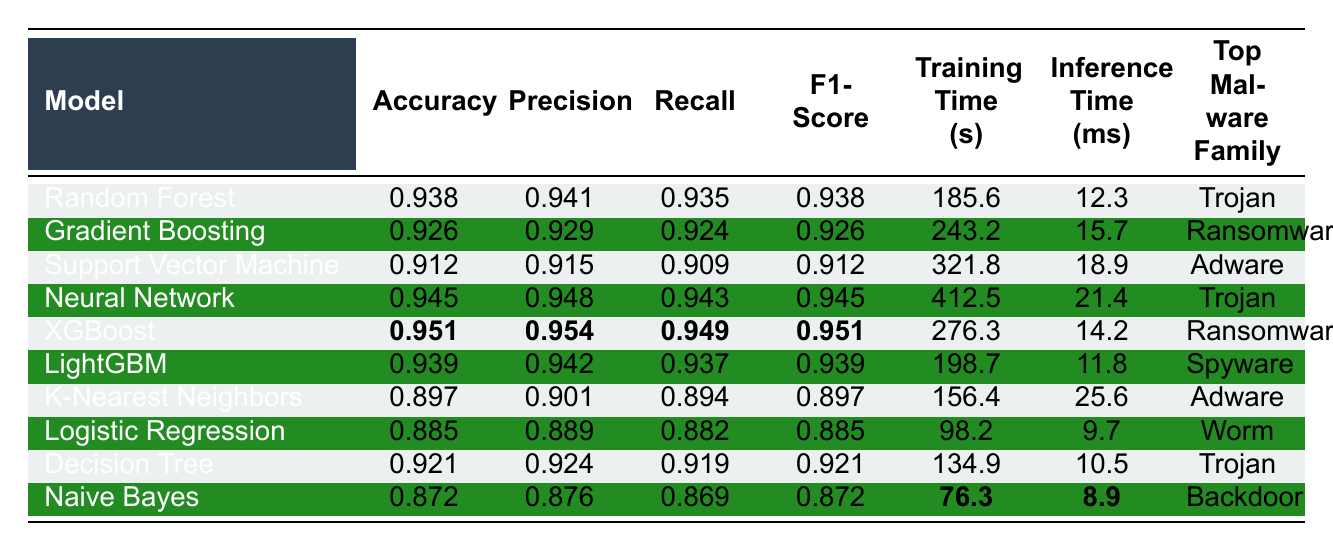What is the highest accuracy achieved by a model? The table lists the accuracy for each model, and by looking at the "Accuracy" column, the highest value is 0.951 for the XGBoost model.
Answer: 0.951 Which model has the shortest inference time? By examining the "Inference Time (ms)" column, the shortest time recorded is 8.9 ms for the Naive Bayes model.
Answer: 8.9 ms Is the Precision of the Neural Network higher than that of the Gradient Boosting model? The Precision for the Neural Network is 0.948, while for the Gradient Boosting model it is 0.929. Since 0.948 > 0.929, the statement is true.
Answer: Yes What is the average F1-Score of all models? To determine the average F1-Score, we add all the F1-Scores together: (0.938 + 0.926 + 0.912 + 0.945 + 0.951 + 0.939 + 0.897 + 0.885 + 0.921 + 0.872) = 9.454. Dividing by the number of models (10), the average F1-Score is 9.454 / 10 = 0.9454.
Answer: 0.9454 Which model has the highest Precision and what is that value? Looking at the "Precision" column, the highest Precision is 0.954, which is associated with the XGBoost model.
Answer: XGBoost, 0.954 Is there any model that identifies "Worm" as the Top Malware Family? Upon reviewing the "Top Malware Family" column, the Logistic Regression model identifies "Worm" as the top malware family.
Answer: Yes What is the difference in training time between the Neural Network and the Logistic Regression model? The training time for the Neural Network is 412.5 seconds, and for the Logistic Regression model, it is 98.2 seconds. The difference is 412.5 - 98.2 = 314.3 seconds.
Answer: 314.3 seconds Identify the models that achieved an accuracy greater than 0.9. By scanning the "Accuracy" column, the models with an accuracy greater than 0.9 are Random Forest, Gradient Boosting, Neural Network, XGBoost, LightGBM, Support Vector Machine, and Decision Tree.
Answer: Random Forest, Gradient Boosting, Neural Network, XGBoost, LightGBM, Support Vector Machine, Decision Tree What is the median of the Training Time for all models? To find the median, we need to organize the training time values: {76.3, 98.2, 134.9, 185.6, 198.7, 243.2, 276.3, 321.8, 412.5}. There are 10 data points so the median is the average of the 5th and 6th values: (198.7 + 243.2) / 2 = 220.95 seconds.
Answer: 220.95 seconds How many models classify "Ransomware" as the Top Malware Family? By reviewing the "Top Malware Family" column, "Ransomware" appears as the top malware family for two models: Gradient Boosting and XGBoost.
Answer: 2 